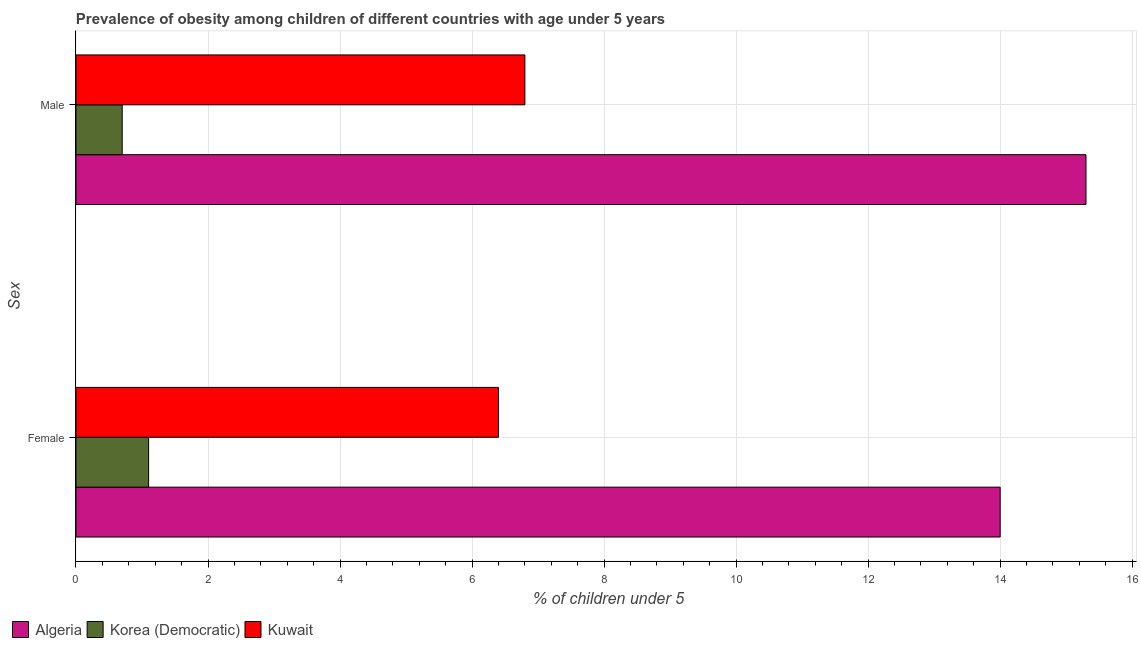How many groups of bars are there?
Keep it short and to the point. 2. Are the number of bars per tick equal to the number of legend labels?
Ensure brevity in your answer.  Yes. Are the number of bars on each tick of the Y-axis equal?
Provide a short and direct response. Yes. How many bars are there on the 1st tick from the bottom?
Make the answer very short. 3. What is the percentage of obese female children in Korea (Democratic)?
Give a very brief answer. 1.1. Across all countries, what is the maximum percentage of obese female children?
Provide a succinct answer. 14. Across all countries, what is the minimum percentage of obese male children?
Ensure brevity in your answer.  0.7. In which country was the percentage of obese male children maximum?
Offer a terse response. Algeria. In which country was the percentage of obese female children minimum?
Provide a succinct answer. Korea (Democratic). What is the total percentage of obese male children in the graph?
Offer a terse response. 22.8. What is the difference between the percentage of obese male children in Algeria and that in Kuwait?
Your answer should be compact. 8.5. What is the difference between the percentage of obese male children in Kuwait and the percentage of obese female children in Korea (Democratic)?
Your answer should be compact. 5.7. What is the average percentage of obese male children per country?
Offer a terse response. 7.6. What is the difference between the percentage of obese female children and percentage of obese male children in Kuwait?
Offer a very short reply. -0.4. What is the ratio of the percentage of obese male children in Kuwait to that in Korea (Democratic)?
Provide a succinct answer. 9.71. Is the percentage of obese male children in Algeria less than that in Kuwait?
Your answer should be very brief. No. What does the 2nd bar from the top in Male represents?
Keep it short and to the point. Korea (Democratic). What does the 3rd bar from the bottom in Female represents?
Give a very brief answer. Kuwait. How many bars are there?
Offer a terse response. 6. How many countries are there in the graph?
Provide a short and direct response. 3. Are the values on the major ticks of X-axis written in scientific E-notation?
Make the answer very short. No. Does the graph contain any zero values?
Offer a very short reply. No. Where does the legend appear in the graph?
Make the answer very short. Bottom left. How many legend labels are there?
Your answer should be very brief. 3. How are the legend labels stacked?
Provide a short and direct response. Horizontal. What is the title of the graph?
Offer a very short reply. Prevalence of obesity among children of different countries with age under 5 years. What is the label or title of the X-axis?
Offer a very short reply.  % of children under 5. What is the label or title of the Y-axis?
Your answer should be very brief. Sex. What is the  % of children under 5 in Algeria in Female?
Make the answer very short. 14. What is the  % of children under 5 of Korea (Democratic) in Female?
Provide a short and direct response. 1.1. What is the  % of children under 5 in Kuwait in Female?
Give a very brief answer. 6.4. What is the  % of children under 5 in Algeria in Male?
Keep it short and to the point. 15.3. What is the  % of children under 5 in Korea (Democratic) in Male?
Provide a short and direct response. 0.7. What is the  % of children under 5 in Kuwait in Male?
Provide a short and direct response. 6.8. Across all Sex, what is the maximum  % of children under 5 of Algeria?
Ensure brevity in your answer.  15.3. Across all Sex, what is the maximum  % of children under 5 in Korea (Democratic)?
Your answer should be very brief. 1.1. Across all Sex, what is the maximum  % of children under 5 of Kuwait?
Ensure brevity in your answer.  6.8. Across all Sex, what is the minimum  % of children under 5 in Korea (Democratic)?
Your answer should be compact. 0.7. Across all Sex, what is the minimum  % of children under 5 of Kuwait?
Your answer should be very brief. 6.4. What is the total  % of children under 5 in Algeria in the graph?
Ensure brevity in your answer.  29.3. What is the total  % of children under 5 of Kuwait in the graph?
Make the answer very short. 13.2. What is the difference between the  % of children under 5 in Algeria in Female and that in Male?
Provide a succinct answer. -1.3. What is the difference between the  % of children under 5 in Kuwait in Female and that in Male?
Your response must be concise. -0.4. What is the difference between the  % of children under 5 in Algeria in Female and the  % of children under 5 in Kuwait in Male?
Offer a terse response. 7.2. What is the difference between the  % of children under 5 of Korea (Democratic) in Female and the  % of children under 5 of Kuwait in Male?
Offer a terse response. -5.7. What is the average  % of children under 5 in Algeria per Sex?
Give a very brief answer. 14.65. What is the average  % of children under 5 of Korea (Democratic) per Sex?
Keep it short and to the point. 0.9. What is the difference between the  % of children under 5 of Algeria and  % of children under 5 of Korea (Democratic) in Female?
Make the answer very short. 12.9. What is the difference between the  % of children under 5 in Korea (Democratic) and  % of children under 5 in Kuwait in Female?
Your answer should be very brief. -5.3. What is the difference between the  % of children under 5 in Korea (Democratic) and  % of children under 5 in Kuwait in Male?
Provide a short and direct response. -6.1. What is the ratio of the  % of children under 5 of Algeria in Female to that in Male?
Offer a very short reply. 0.92. What is the ratio of the  % of children under 5 in Korea (Democratic) in Female to that in Male?
Provide a succinct answer. 1.57. What is the difference between the highest and the lowest  % of children under 5 in Algeria?
Offer a terse response. 1.3. What is the difference between the highest and the lowest  % of children under 5 in Korea (Democratic)?
Offer a terse response. 0.4. 